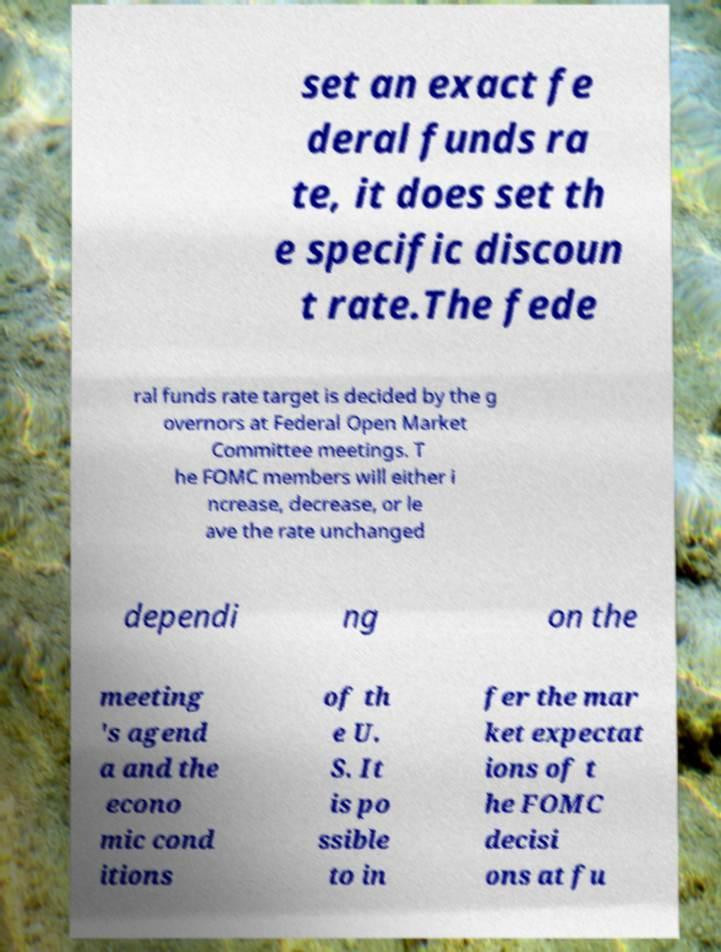Please identify and transcribe the text found in this image. set an exact fe deral funds ra te, it does set th e specific discoun t rate.The fede ral funds rate target is decided by the g overnors at Federal Open Market Committee meetings. T he FOMC members will either i ncrease, decrease, or le ave the rate unchanged dependi ng on the meeting 's agend a and the econo mic cond itions of th e U. S. It is po ssible to in fer the mar ket expectat ions of t he FOMC decisi ons at fu 